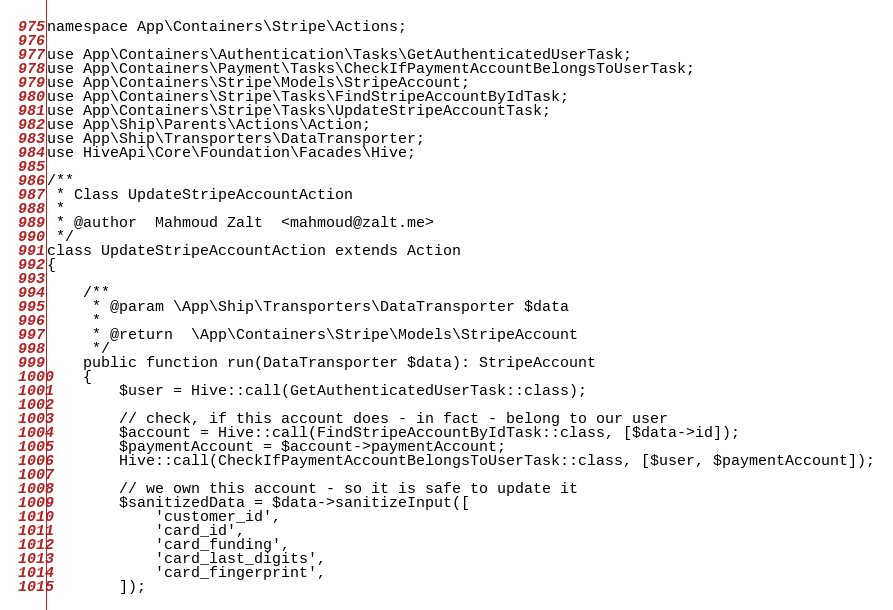<code> <loc_0><loc_0><loc_500><loc_500><_PHP_>namespace App\Containers\Stripe\Actions;

use App\Containers\Authentication\Tasks\GetAuthenticatedUserTask;
use App\Containers\Payment\Tasks\CheckIfPaymentAccountBelongsToUserTask;
use App\Containers\Stripe\Models\StripeAccount;
use App\Containers\Stripe\Tasks\FindStripeAccountByIdTask;
use App\Containers\Stripe\Tasks\UpdateStripeAccountTask;
use App\Ship\Parents\Actions\Action;
use App\Ship\Transporters\DataTransporter;
use HiveApi\Core\Foundation\Facades\Hive;

/**
 * Class UpdateStripeAccountAction
 *
 * @author  Mahmoud Zalt  <mahmoud@zalt.me>
 */
class UpdateStripeAccountAction extends Action
{

    /**
     * @param \App\Ship\Transporters\DataTransporter $data
     *
     * @return  \App\Containers\Stripe\Models\StripeAccount
     */
    public function run(DataTransporter $data): StripeAccount
    {
        $user = Hive::call(GetAuthenticatedUserTask::class);

        // check, if this account does - in fact - belong to our user
        $account = Hive::call(FindStripeAccountByIdTask::class, [$data->id]);
        $paymentAccount = $account->paymentAccount;
        Hive::call(CheckIfPaymentAccountBelongsToUserTask::class, [$user, $paymentAccount]);

        // we own this account - so it is safe to update it
        $sanitizedData = $data->sanitizeInput([
            'customer_id',
            'card_id',
            'card_funding',
            'card_last_digits',
            'card_fingerprint',
        ]);
</code> 